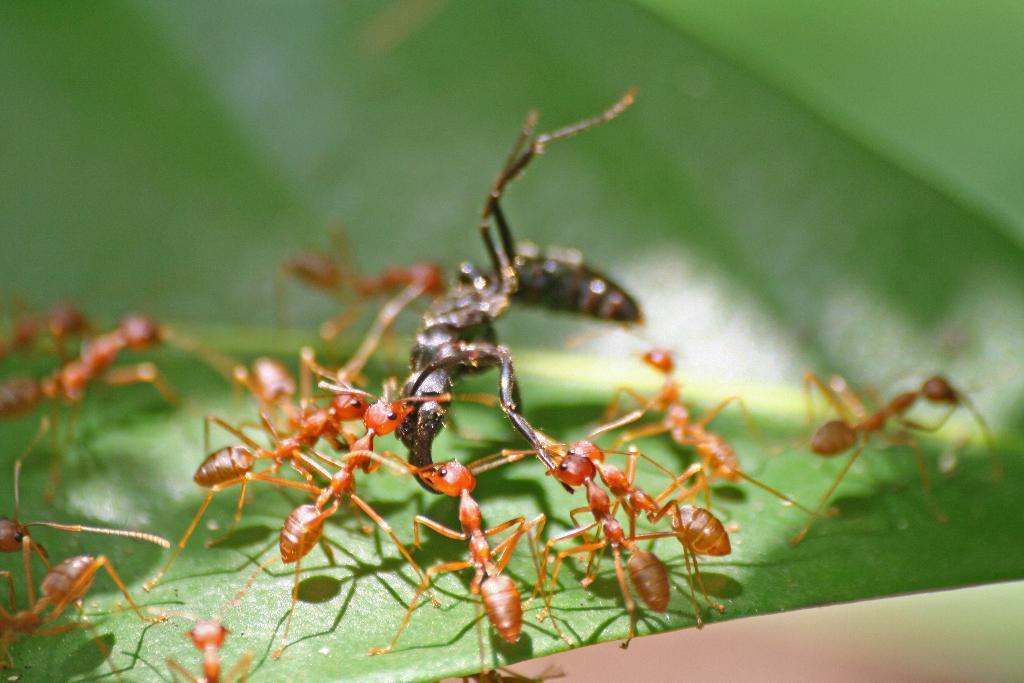Please provide a concise description of this image. In this image, we can see ants are on the green leaf. In the background, there is a blur view. 